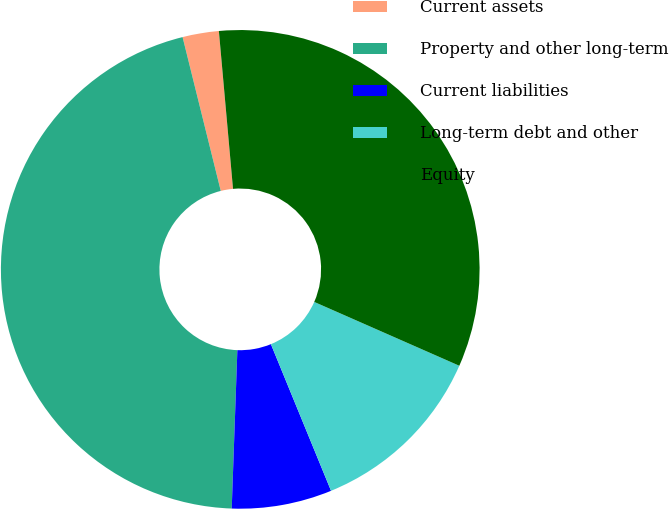Convert chart to OTSL. <chart><loc_0><loc_0><loc_500><loc_500><pie_chart><fcel>Current assets<fcel>Property and other long-term<fcel>Current liabilities<fcel>Long-term debt and other<fcel>Equity<nl><fcel>2.45%<fcel>45.56%<fcel>6.76%<fcel>12.21%<fcel>33.02%<nl></chart> 